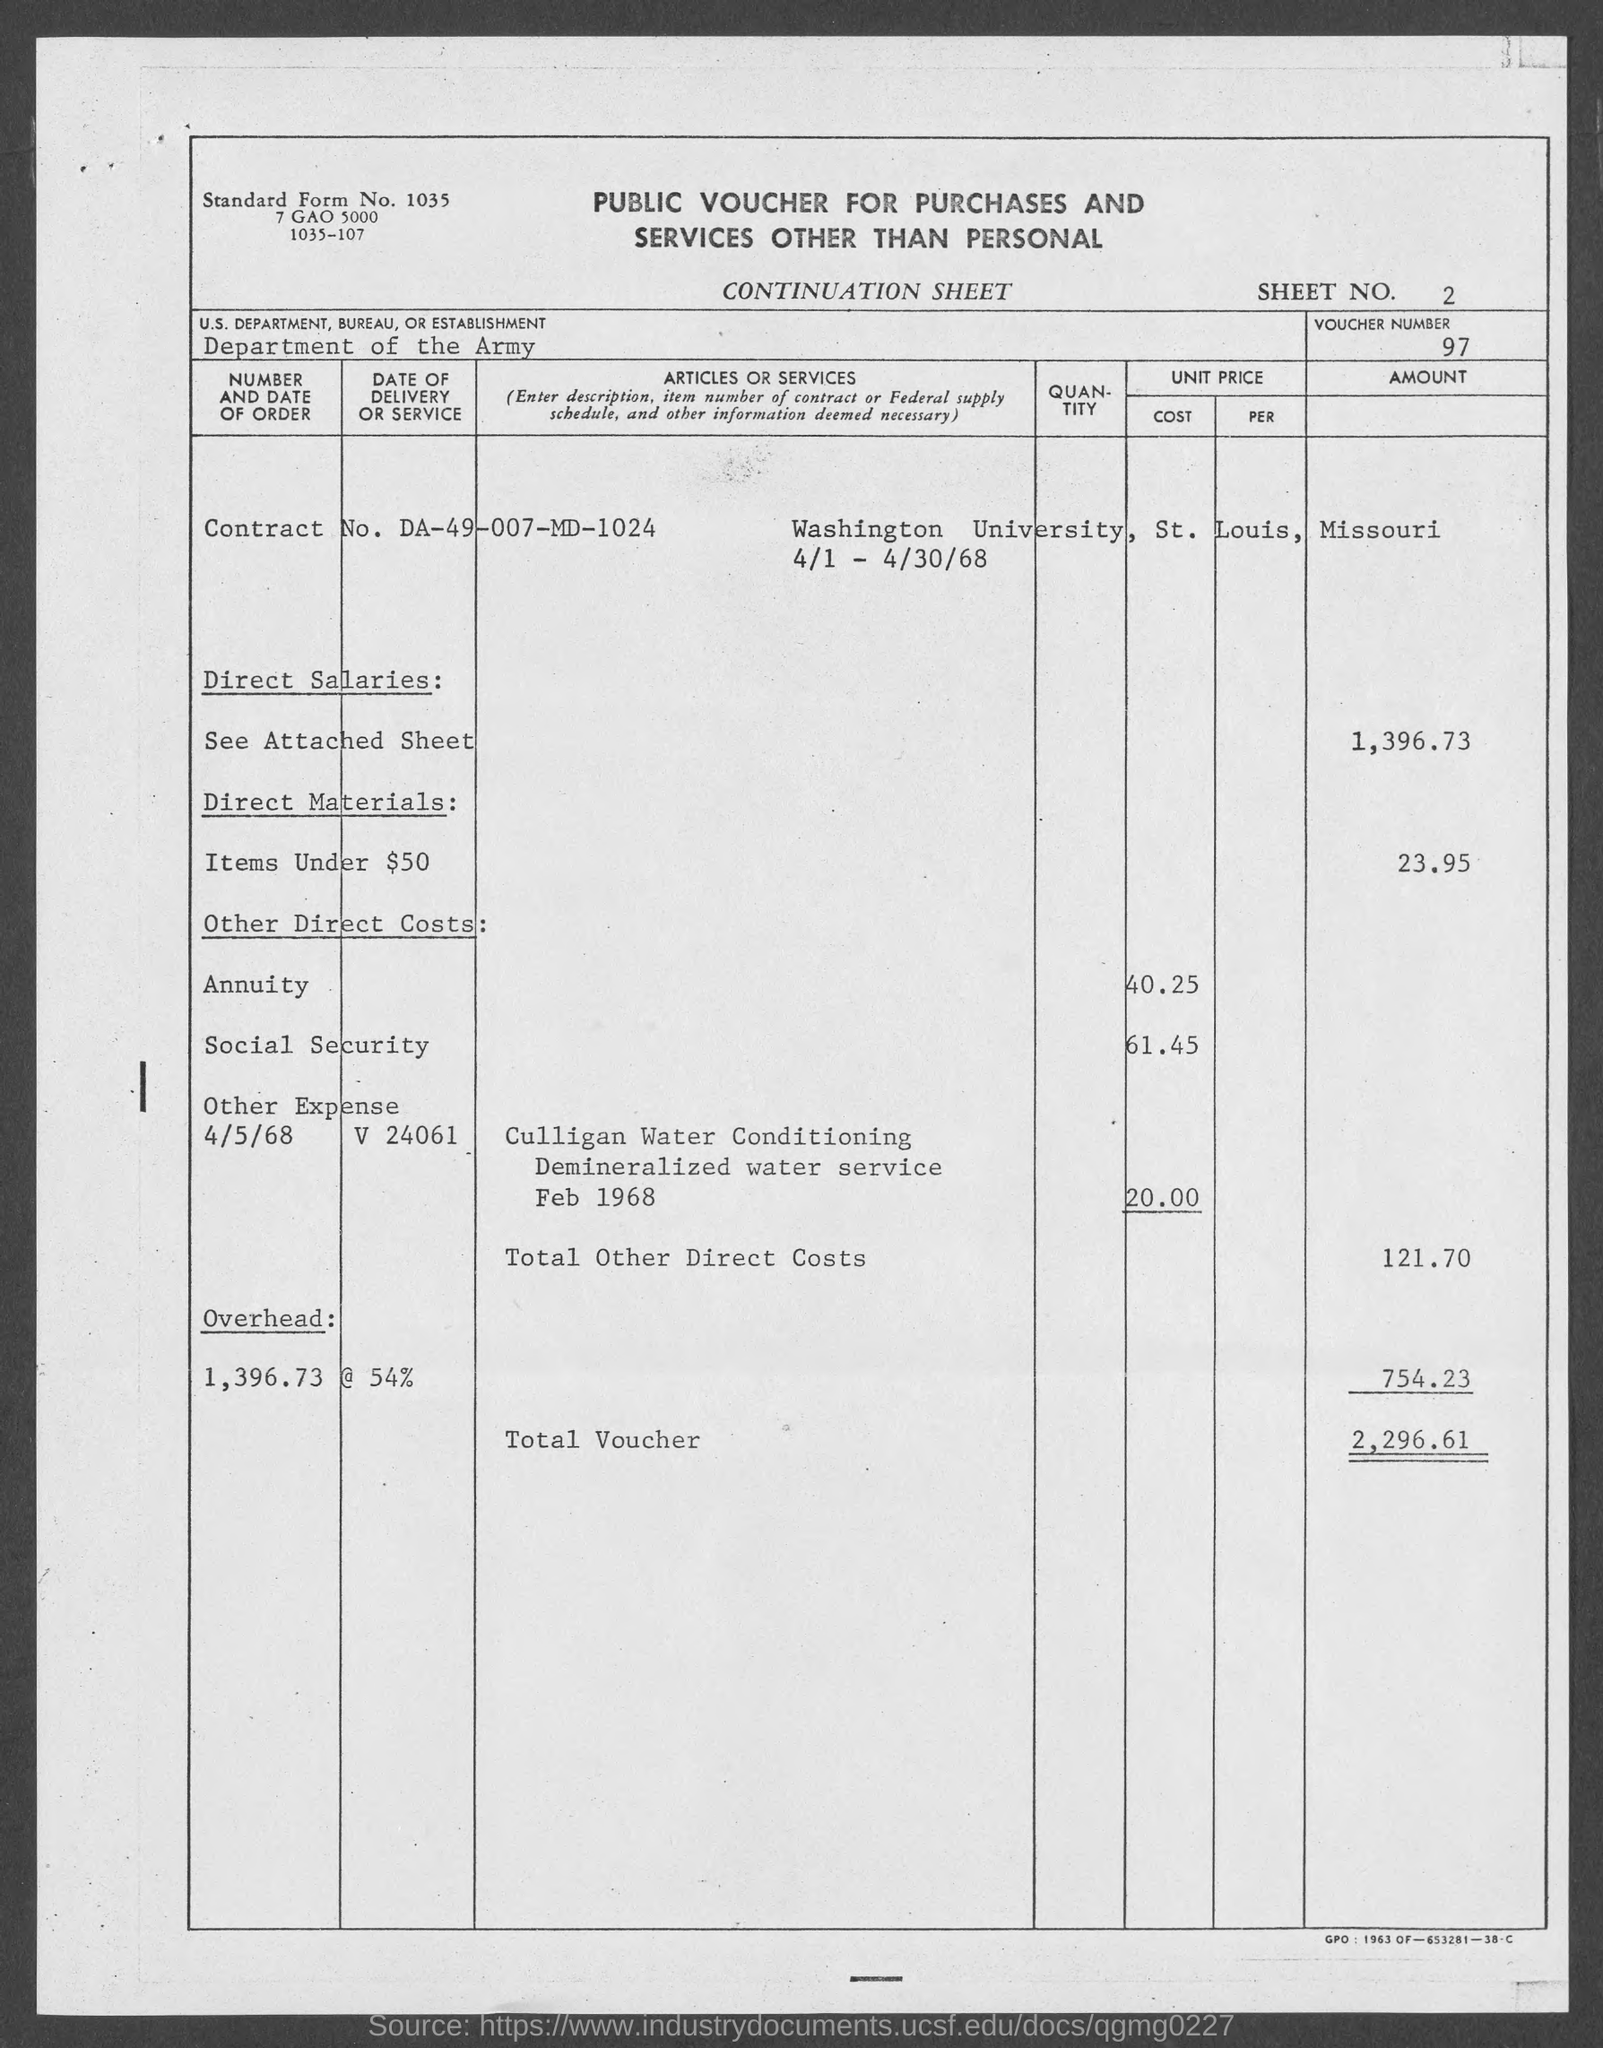What is the Standard Form No. given in the voucher?
Provide a short and direct response. 1035. What is the Sheet No. mentioned in the voucher?
Offer a terse response. 2. What is the voucher number given in the document?
Make the answer very short. 97. What is the U.S. Department, Bureau, or Establishment given in the voucher?
Your answer should be compact. DEPARTMENT OF THE ARMY. What is the Contract No. given in the voucher?
Provide a succinct answer. DA-49-007-MD-1024. What is the Direct material cost (Items under $50) given in the voucher?
Give a very brief answer. 23.95. What is the direct salaries cost mentioned in the voucher?
Offer a very short reply. 1,396.73. What is the social security cost mentioned in the voucher?
Your answer should be very brief. 61.45. What is the overhead cost given in the voucher?
Keep it short and to the point. 754.23. What is the total voucher amount mentioned in the document?
Your answer should be very brief. 2,296.61. 